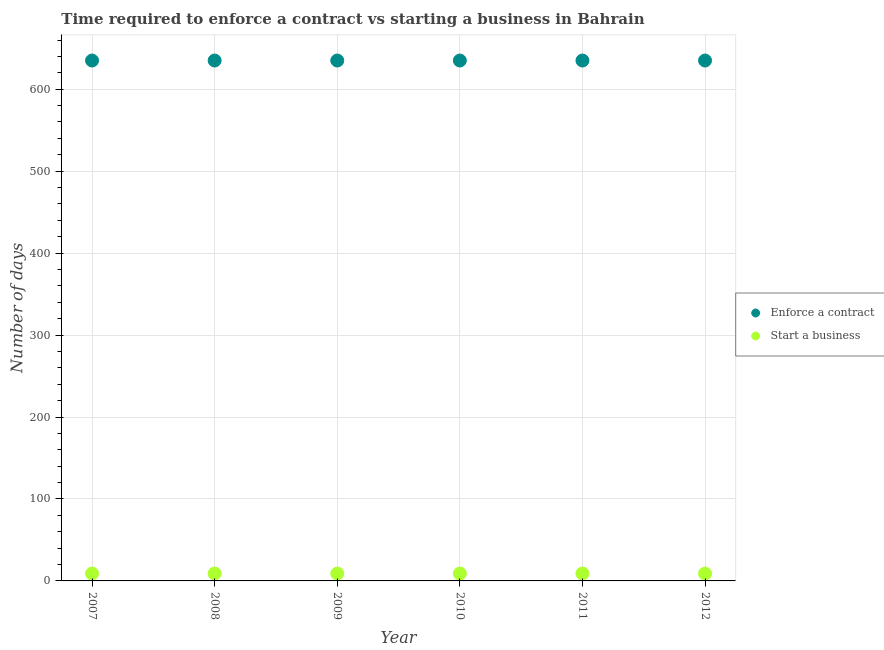How many different coloured dotlines are there?
Ensure brevity in your answer.  2. What is the number of days to enforece a contract in 2008?
Offer a very short reply. 635. Across all years, what is the maximum number of days to enforece a contract?
Your answer should be very brief. 635. Across all years, what is the minimum number of days to start a business?
Offer a terse response. 9. In which year was the number of days to enforece a contract maximum?
Give a very brief answer. 2007. What is the total number of days to enforece a contract in the graph?
Offer a terse response. 3810. What is the difference between the number of days to start a business in 2007 and the number of days to enforece a contract in 2010?
Make the answer very short. -626. What is the average number of days to enforece a contract per year?
Provide a succinct answer. 635. In the year 2011, what is the difference between the number of days to start a business and number of days to enforece a contract?
Your response must be concise. -626. What is the ratio of the number of days to start a business in 2008 to that in 2009?
Provide a succinct answer. 1. Is the number of days to start a business in 2008 less than that in 2012?
Give a very brief answer. No. In how many years, is the number of days to enforece a contract greater than the average number of days to enforece a contract taken over all years?
Provide a short and direct response. 0. Is the sum of the number of days to enforece a contract in 2011 and 2012 greater than the maximum number of days to start a business across all years?
Your response must be concise. Yes. Is the number of days to enforece a contract strictly greater than the number of days to start a business over the years?
Ensure brevity in your answer.  Yes. What is the difference between two consecutive major ticks on the Y-axis?
Give a very brief answer. 100. Are the values on the major ticks of Y-axis written in scientific E-notation?
Give a very brief answer. No. Does the graph contain any zero values?
Ensure brevity in your answer.  No. How many legend labels are there?
Ensure brevity in your answer.  2. What is the title of the graph?
Ensure brevity in your answer.  Time required to enforce a contract vs starting a business in Bahrain. Does "Manufacturing industries and construction" appear as one of the legend labels in the graph?
Your answer should be compact. No. What is the label or title of the X-axis?
Provide a short and direct response. Year. What is the label or title of the Y-axis?
Provide a short and direct response. Number of days. What is the Number of days in Enforce a contract in 2007?
Your response must be concise. 635. What is the Number of days of Start a business in 2007?
Keep it short and to the point. 9. What is the Number of days in Enforce a contract in 2008?
Ensure brevity in your answer.  635. What is the Number of days in Enforce a contract in 2009?
Ensure brevity in your answer.  635. What is the Number of days in Start a business in 2009?
Offer a very short reply. 9. What is the Number of days in Enforce a contract in 2010?
Your answer should be compact. 635. What is the Number of days in Start a business in 2010?
Make the answer very short. 9. What is the Number of days in Enforce a contract in 2011?
Your response must be concise. 635. What is the Number of days in Start a business in 2011?
Provide a succinct answer. 9. What is the Number of days in Enforce a contract in 2012?
Provide a succinct answer. 635. What is the Number of days of Start a business in 2012?
Offer a very short reply. 9. Across all years, what is the maximum Number of days of Enforce a contract?
Provide a short and direct response. 635. Across all years, what is the maximum Number of days of Start a business?
Ensure brevity in your answer.  9. Across all years, what is the minimum Number of days of Enforce a contract?
Provide a succinct answer. 635. Across all years, what is the minimum Number of days in Start a business?
Offer a very short reply. 9. What is the total Number of days of Enforce a contract in the graph?
Your response must be concise. 3810. What is the total Number of days of Start a business in the graph?
Offer a terse response. 54. What is the difference between the Number of days in Enforce a contract in 2007 and that in 2009?
Ensure brevity in your answer.  0. What is the difference between the Number of days of Enforce a contract in 2007 and that in 2010?
Keep it short and to the point. 0. What is the difference between the Number of days in Start a business in 2007 and that in 2010?
Keep it short and to the point. 0. What is the difference between the Number of days in Enforce a contract in 2007 and that in 2011?
Make the answer very short. 0. What is the difference between the Number of days in Enforce a contract in 2008 and that in 2009?
Provide a succinct answer. 0. What is the difference between the Number of days of Start a business in 2008 and that in 2009?
Give a very brief answer. 0. What is the difference between the Number of days in Enforce a contract in 2008 and that in 2012?
Offer a terse response. 0. What is the difference between the Number of days of Start a business in 2008 and that in 2012?
Offer a terse response. 0. What is the difference between the Number of days of Enforce a contract in 2009 and that in 2010?
Offer a terse response. 0. What is the difference between the Number of days of Start a business in 2009 and that in 2010?
Your answer should be very brief. 0. What is the difference between the Number of days in Enforce a contract in 2009 and that in 2011?
Provide a succinct answer. 0. What is the difference between the Number of days in Start a business in 2009 and that in 2011?
Keep it short and to the point. 0. What is the difference between the Number of days of Start a business in 2010 and that in 2011?
Ensure brevity in your answer.  0. What is the difference between the Number of days in Start a business in 2010 and that in 2012?
Ensure brevity in your answer.  0. What is the difference between the Number of days of Enforce a contract in 2011 and that in 2012?
Your answer should be very brief. 0. What is the difference between the Number of days in Start a business in 2011 and that in 2012?
Ensure brevity in your answer.  0. What is the difference between the Number of days of Enforce a contract in 2007 and the Number of days of Start a business in 2008?
Keep it short and to the point. 626. What is the difference between the Number of days in Enforce a contract in 2007 and the Number of days in Start a business in 2009?
Ensure brevity in your answer.  626. What is the difference between the Number of days in Enforce a contract in 2007 and the Number of days in Start a business in 2010?
Your answer should be compact. 626. What is the difference between the Number of days of Enforce a contract in 2007 and the Number of days of Start a business in 2011?
Ensure brevity in your answer.  626. What is the difference between the Number of days of Enforce a contract in 2007 and the Number of days of Start a business in 2012?
Offer a terse response. 626. What is the difference between the Number of days in Enforce a contract in 2008 and the Number of days in Start a business in 2009?
Ensure brevity in your answer.  626. What is the difference between the Number of days of Enforce a contract in 2008 and the Number of days of Start a business in 2010?
Offer a very short reply. 626. What is the difference between the Number of days in Enforce a contract in 2008 and the Number of days in Start a business in 2011?
Your answer should be compact. 626. What is the difference between the Number of days in Enforce a contract in 2008 and the Number of days in Start a business in 2012?
Your answer should be compact. 626. What is the difference between the Number of days of Enforce a contract in 2009 and the Number of days of Start a business in 2010?
Your answer should be very brief. 626. What is the difference between the Number of days in Enforce a contract in 2009 and the Number of days in Start a business in 2011?
Offer a very short reply. 626. What is the difference between the Number of days in Enforce a contract in 2009 and the Number of days in Start a business in 2012?
Ensure brevity in your answer.  626. What is the difference between the Number of days in Enforce a contract in 2010 and the Number of days in Start a business in 2011?
Offer a very short reply. 626. What is the difference between the Number of days in Enforce a contract in 2010 and the Number of days in Start a business in 2012?
Ensure brevity in your answer.  626. What is the difference between the Number of days in Enforce a contract in 2011 and the Number of days in Start a business in 2012?
Provide a short and direct response. 626. What is the average Number of days in Enforce a contract per year?
Offer a terse response. 635. What is the average Number of days of Start a business per year?
Offer a very short reply. 9. In the year 2007, what is the difference between the Number of days in Enforce a contract and Number of days in Start a business?
Provide a succinct answer. 626. In the year 2008, what is the difference between the Number of days in Enforce a contract and Number of days in Start a business?
Your answer should be very brief. 626. In the year 2009, what is the difference between the Number of days of Enforce a contract and Number of days of Start a business?
Offer a terse response. 626. In the year 2010, what is the difference between the Number of days in Enforce a contract and Number of days in Start a business?
Your answer should be compact. 626. In the year 2011, what is the difference between the Number of days of Enforce a contract and Number of days of Start a business?
Offer a terse response. 626. In the year 2012, what is the difference between the Number of days in Enforce a contract and Number of days in Start a business?
Provide a short and direct response. 626. What is the ratio of the Number of days of Enforce a contract in 2007 to that in 2008?
Offer a terse response. 1. What is the ratio of the Number of days in Start a business in 2007 to that in 2008?
Your answer should be very brief. 1. What is the ratio of the Number of days of Start a business in 2007 to that in 2009?
Offer a very short reply. 1. What is the ratio of the Number of days of Start a business in 2007 to that in 2010?
Keep it short and to the point. 1. What is the ratio of the Number of days of Enforce a contract in 2007 to that in 2012?
Your response must be concise. 1. What is the ratio of the Number of days in Enforce a contract in 2008 to that in 2009?
Your answer should be very brief. 1. What is the ratio of the Number of days in Start a business in 2008 to that in 2009?
Your answer should be very brief. 1. What is the ratio of the Number of days of Enforce a contract in 2008 to that in 2010?
Your response must be concise. 1. What is the ratio of the Number of days in Start a business in 2008 to that in 2010?
Provide a succinct answer. 1. What is the ratio of the Number of days of Enforce a contract in 2008 to that in 2012?
Your response must be concise. 1. What is the ratio of the Number of days in Start a business in 2008 to that in 2012?
Your response must be concise. 1. What is the ratio of the Number of days in Start a business in 2009 to that in 2010?
Ensure brevity in your answer.  1. What is the ratio of the Number of days in Enforce a contract in 2010 to that in 2012?
Make the answer very short. 1. What is the ratio of the Number of days of Enforce a contract in 2011 to that in 2012?
Keep it short and to the point. 1. What is the ratio of the Number of days of Start a business in 2011 to that in 2012?
Keep it short and to the point. 1. What is the difference between the highest and the second highest Number of days in Start a business?
Your answer should be compact. 0. What is the difference between the highest and the lowest Number of days in Enforce a contract?
Offer a very short reply. 0. What is the difference between the highest and the lowest Number of days in Start a business?
Offer a very short reply. 0. 